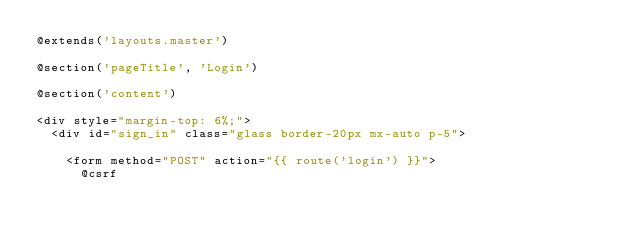Convert code to text. <code><loc_0><loc_0><loc_500><loc_500><_PHP_>@extends('layouts.master')

@section('pageTitle', 'Login')

@section('content')

<div style="margin-top: 6%;">
  <div id="sign_in" class="glass border-20px mx-auto p-5">

    <form method="POST" action="{{ route('login') }}">
      @csrf
</code> 